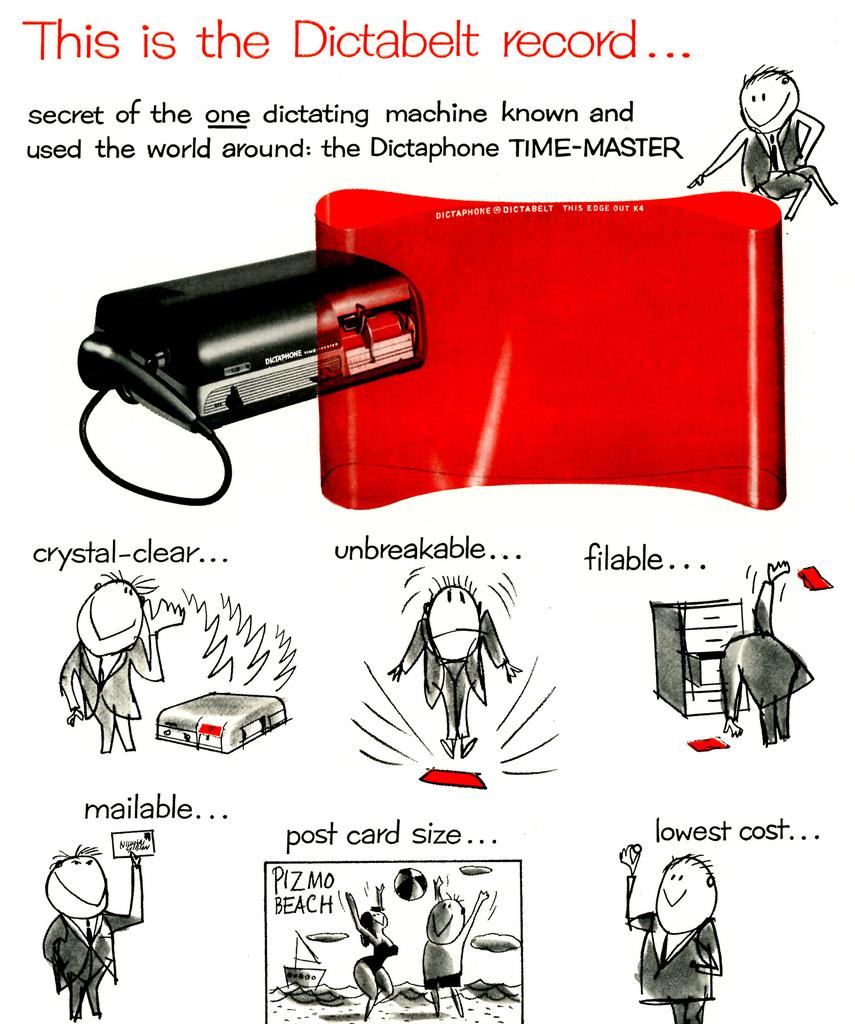What name is this device know world around by?
Give a very brief answer. Dictaphone time-master. Is this unbreakable?
Your answer should be very brief. Yes. 